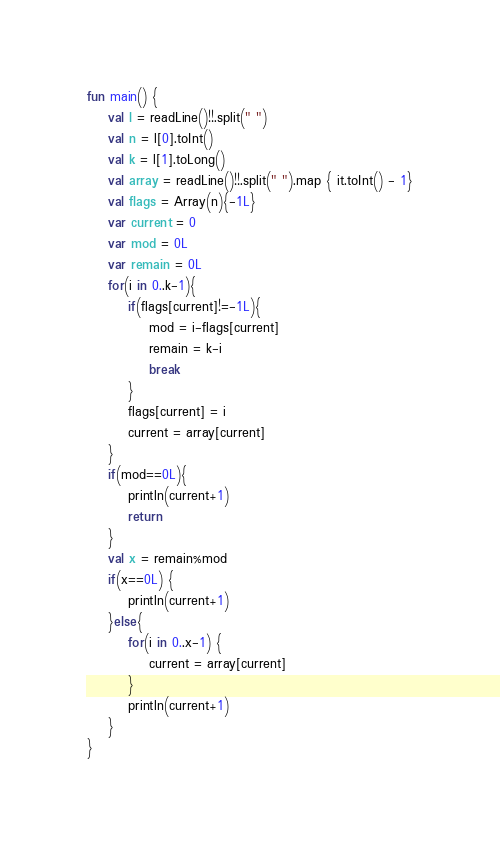<code> <loc_0><loc_0><loc_500><loc_500><_Kotlin_>fun main() {
    val l = readLine()!!.split(" ")
    val n = l[0].toInt()
    val k = l[1].toLong()
    val array = readLine()!!.split(" ").map { it.toInt() - 1}
    val flags = Array(n){-1L}
    var current = 0
    var mod = 0L
    var remain = 0L
    for(i in 0..k-1){
        if(flags[current]!=-1L){
            mod = i-flags[current]
            remain = k-i
            break
        }
        flags[current] = i
        current = array[current]
    }
    if(mod==0L){
        println(current+1)
        return
    }
    val x = remain%mod
    if(x==0L) {
        println(current+1)
    }else{
        for(i in 0..x-1) {
            current = array[current]
        }
        println(current+1)
    }
}</code> 